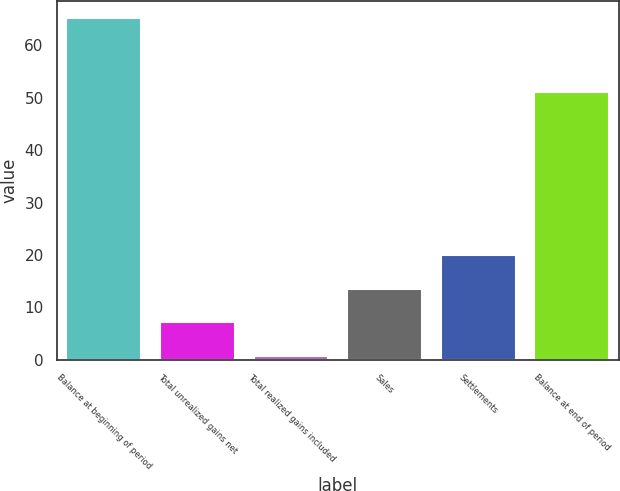<chart> <loc_0><loc_0><loc_500><loc_500><bar_chart><fcel>Balance at beginning of period<fcel>Total unrealized gains net<fcel>Total realized gains included<fcel>Sales<fcel>Settlements<fcel>Balance at end of period<nl><fcel>65.1<fcel>7.14<fcel>0.7<fcel>13.58<fcel>20.02<fcel>51<nl></chart> 